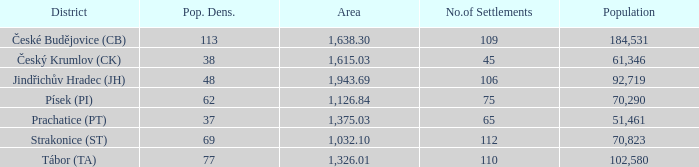How big is the area that has a population density of 113 and a population larger than 184,531? 0.0. 